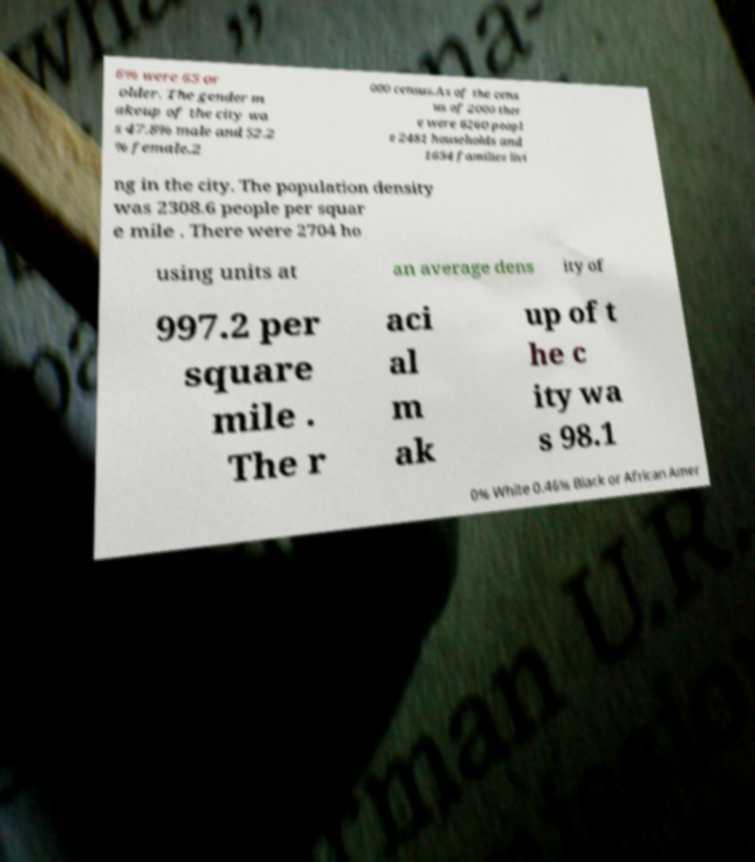I need the written content from this picture converted into text. Can you do that? 6% were 65 or older. The gender m akeup of the city wa s 47.8% male and 52.2 % female.2 000 census.As of the cens us of 2000 ther e were 6260 peopl e 2481 households and 1654 families livi ng in the city. The population density was 2308.6 people per squar e mile . There were 2704 ho using units at an average dens ity of 997.2 per square mile . The r aci al m ak up of t he c ity wa s 98.1 0% White 0.46% Black or African Amer 